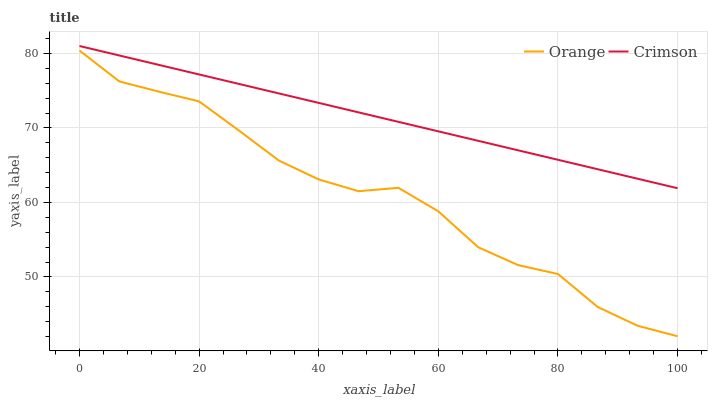Does Orange have the minimum area under the curve?
Answer yes or no. Yes. Does Crimson have the maximum area under the curve?
Answer yes or no. Yes. Does Crimson have the minimum area under the curve?
Answer yes or no. No. Is Crimson the smoothest?
Answer yes or no. Yes. Is Orange the roughest?
Answer yes or no. Yes. Is Crimson the roughest?
Answer yes or no. No. Does Orange have the lowest value?
Answer yes or no. Yes. Does Crimson have the lowest value?
Answer yes or no. No. Does Crimson have the highest value?
Answer yes or no. Yes. Is Orange less than Crimson?
Answer yes or no. Yes. Is Crimson greater than Orange?
Answer yes or no. Yes. Does Orange intersect Crimson?
Answer yes or no. No. 